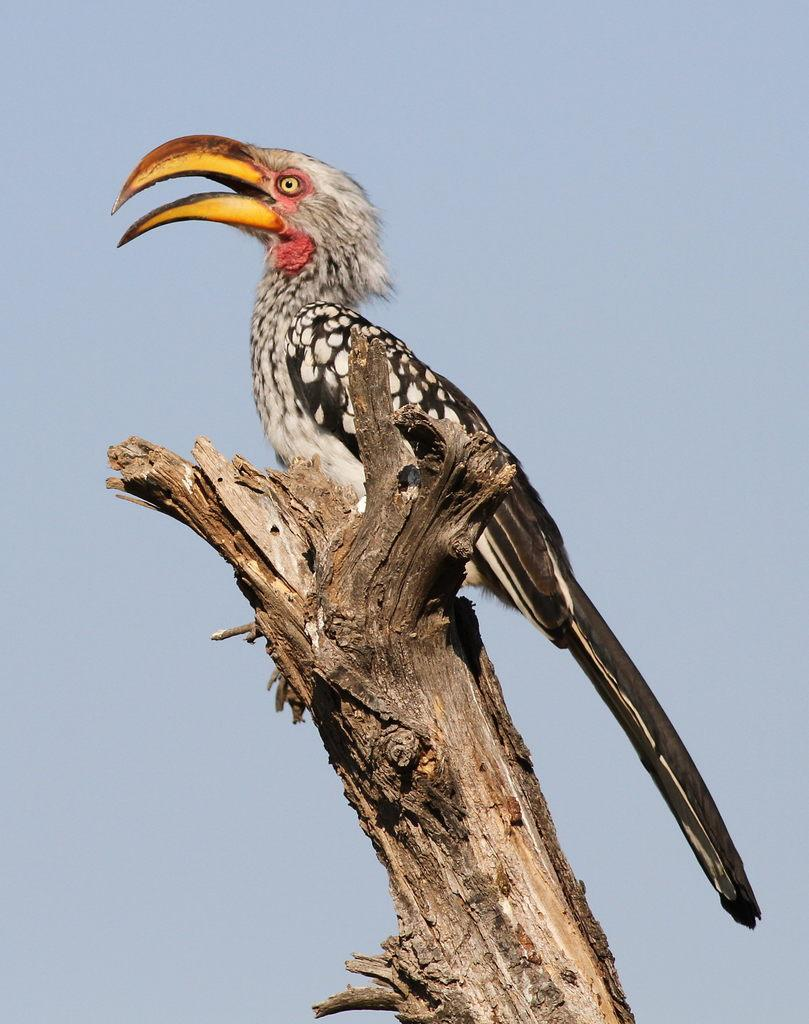What type of animal can be seen in the image? There is a bird in the image. What color is the bird in the image? The bird is in black and white color. Where is the bird located in the image? The bird is on a branch. What can be seen in the background of the image? The sky is visible in the image. What colors are present in the sky in the image? The sky is in blue and white color. Are there any boats visible in the image? No, there are no boats present in the image. What type of hall can be seen in the image? There is no hall present in the image; it features a bird on a branch with a blue and white sky in the background. 